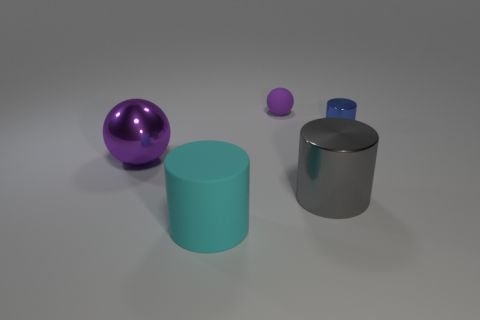There is a thing on the right side of the large metallic object in front of the purple object left of the rubber ball; how big is it?
Provide a succinct answer. Small. How many other objects are the same shape as the blue shiny object?
Your answer should be compact. 2. Do the sphere that is in front of the tiny blue metal object and the ball that is behind the big ball have the same color?
Keep it short and to the point. Yes. There is a metallic cylinder that is the same size as the purple metallic sphere; what color is it?
Make the answer very short. Gray. Is there a shiny ball of the same color as the small rubber thing?
Your response must be concise. Yes. There is a ball that is in front of the purple matte object; is its size the same as the big cyan rubber cylinder?
Keep it short and to the point. Yes. Are there an equal number of gray cylinders that are behind the tiny blue metal thing and big matte balls?
Your response must be concise. Yes. How many objects are objects right of the rubber sphere or purple matte cubes?
Give a very brief answer. 2. There is a thing that is both behind the big gray shiny cylinder and to the left of the small matte sphere; what shape is it?
Provide a short and direct response. Sphere. What number of things are shiny objects on the right side of the cyan matte cylinder or purple objects left of the large rubber thing?
Offer a very short reply. 3. 